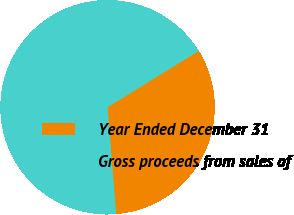Convert chart. <chart><loc_0><loc_0><loc_500><loc_500><pie_chart><fcel>Year Ended December 31<fcel>Gross proceeds from sales of<nl><fcel>32.54%<fcel>67.46%<nl></chart> 